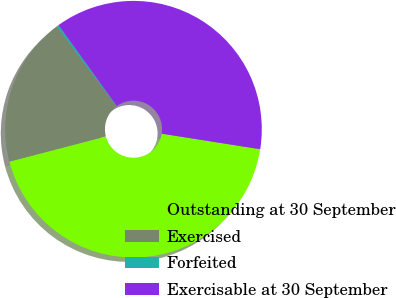Convert chart. <chart><loc_0><loc_0><loc_500><loc_500><pie_chart><fcel>Outstanding at 30 September<fcel>Exercised<fcel>Forfeited<fcel>Exercisable at 30 September<nl><fcel>43.45%<fcel>18.86%<fcel>0.28%<fcel>37.42%<nl></chart> 